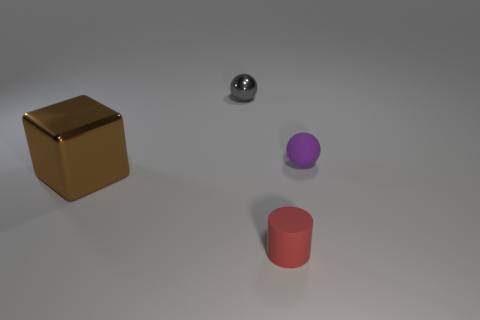Add 4 tiny balls. How many objects exist? 8 Subtract all blocks. How many objects are left? 3 Add 4 small yellow spheres. How many small yellow spheres exist? 4 Subtract 0 cyan spheres. How many objects are left? 4 Subtract all rubber objects. Subtract all big purple matte objects. How many objects are left? 2 Add 1 tiny rubber balls. How many tiny rubber balls are left? 2 